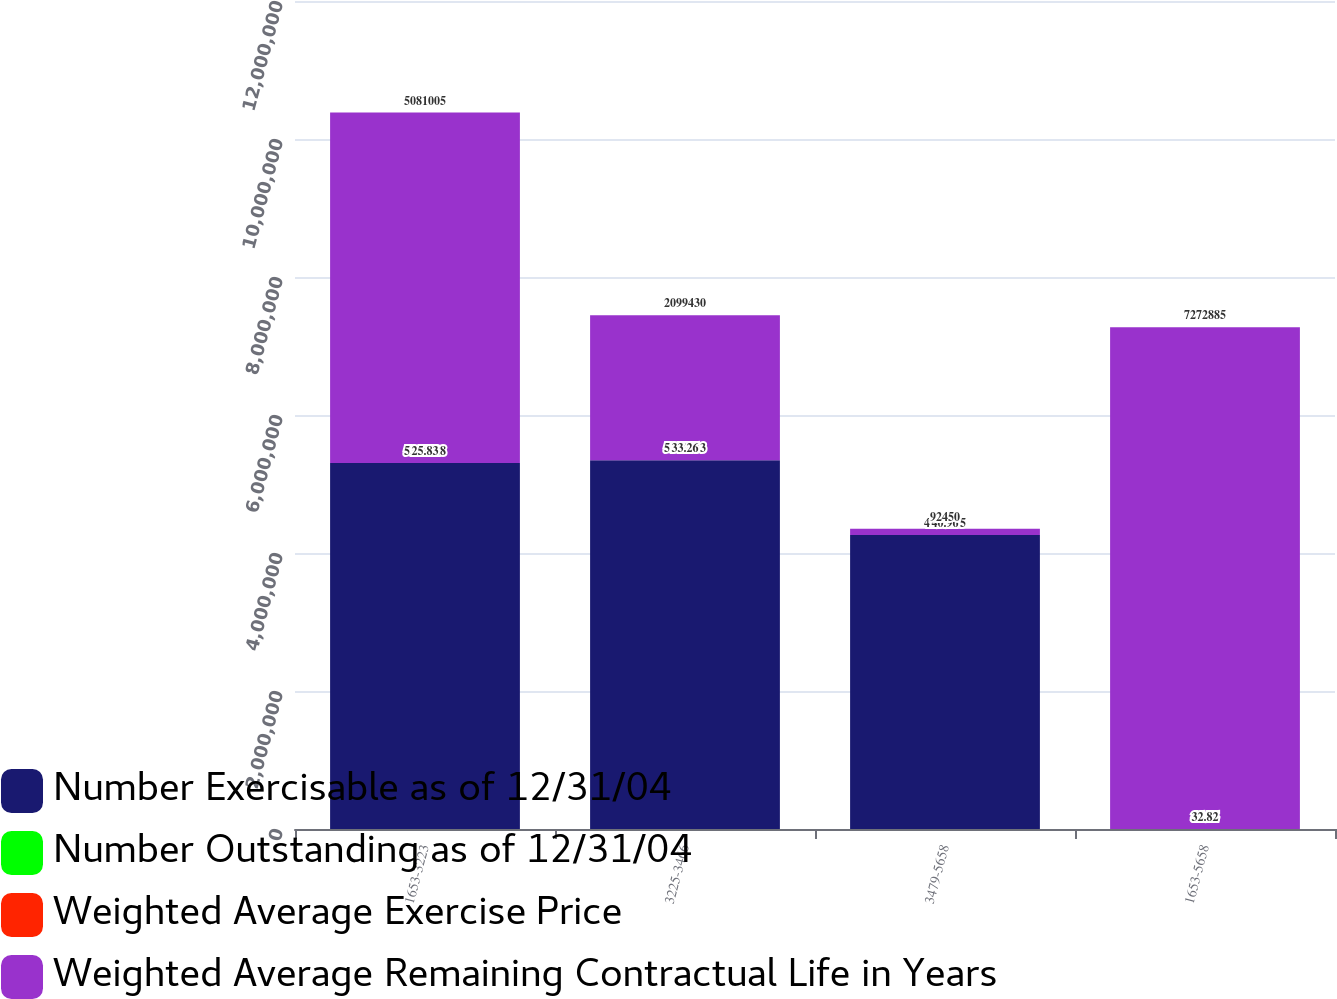Convert chart to OTSL. <chart><loc_0><loc_0><loc_500><loc_500><stacked_bar_chart><ecel><fcel>1653-3223<fcel>3225-3466<fcel>3479-5658<fcel>1653-5658<nl><fcel>Number Exercisable as of 12/31/04<fcel>5.30443e+06<fcel>5.34453e+06<fcel>4.26058e+06<fcel>40.96<nl><fcel>Number Outstanding as of 12/31/04<fcel>4.1<fcel>7.4<fcel>9.2<fcel>6.7<nl><fcel>Weighted Average Exercise Price<fcel>25.83<fcel>33.26<fcel>40.96<fcel>32.82<nl><fcel>Weighted Average Remaining Contractual Life in Years<fcel>5.081e+06<fcel>2.09943e+06<fcel>92450<fcel>7.27288e+06<nl></chart> 